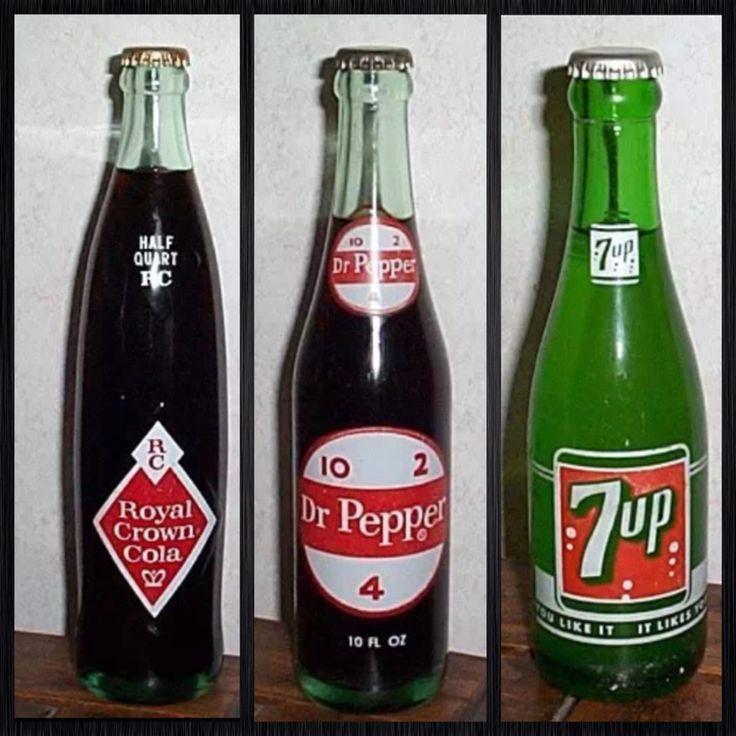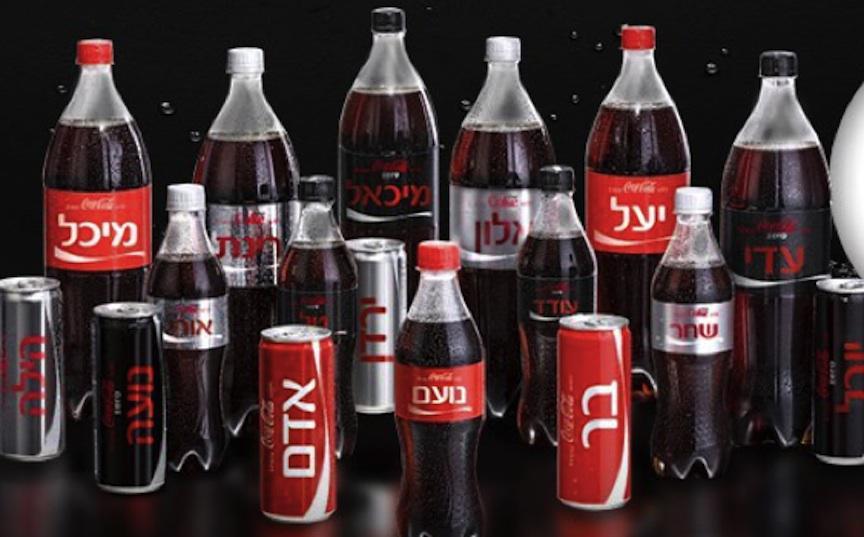The first image is the image on the left, the second image is the image on the right. Assess this claim about the two images: "The left image shows a row of at least three different glass soda bottles, and the right image includes multiple filled plastic soda bottles with different labels.". Correct or not? Answer yes or no. Yes. The first image is the image on the left, the second image is the image on the right. Given the left and right images, does the statement "Rows of red-capped cola bottles with red and white labels are in one image, all but one with a second white rectangular label on the neck." hold true? Answer yes or no. No. 